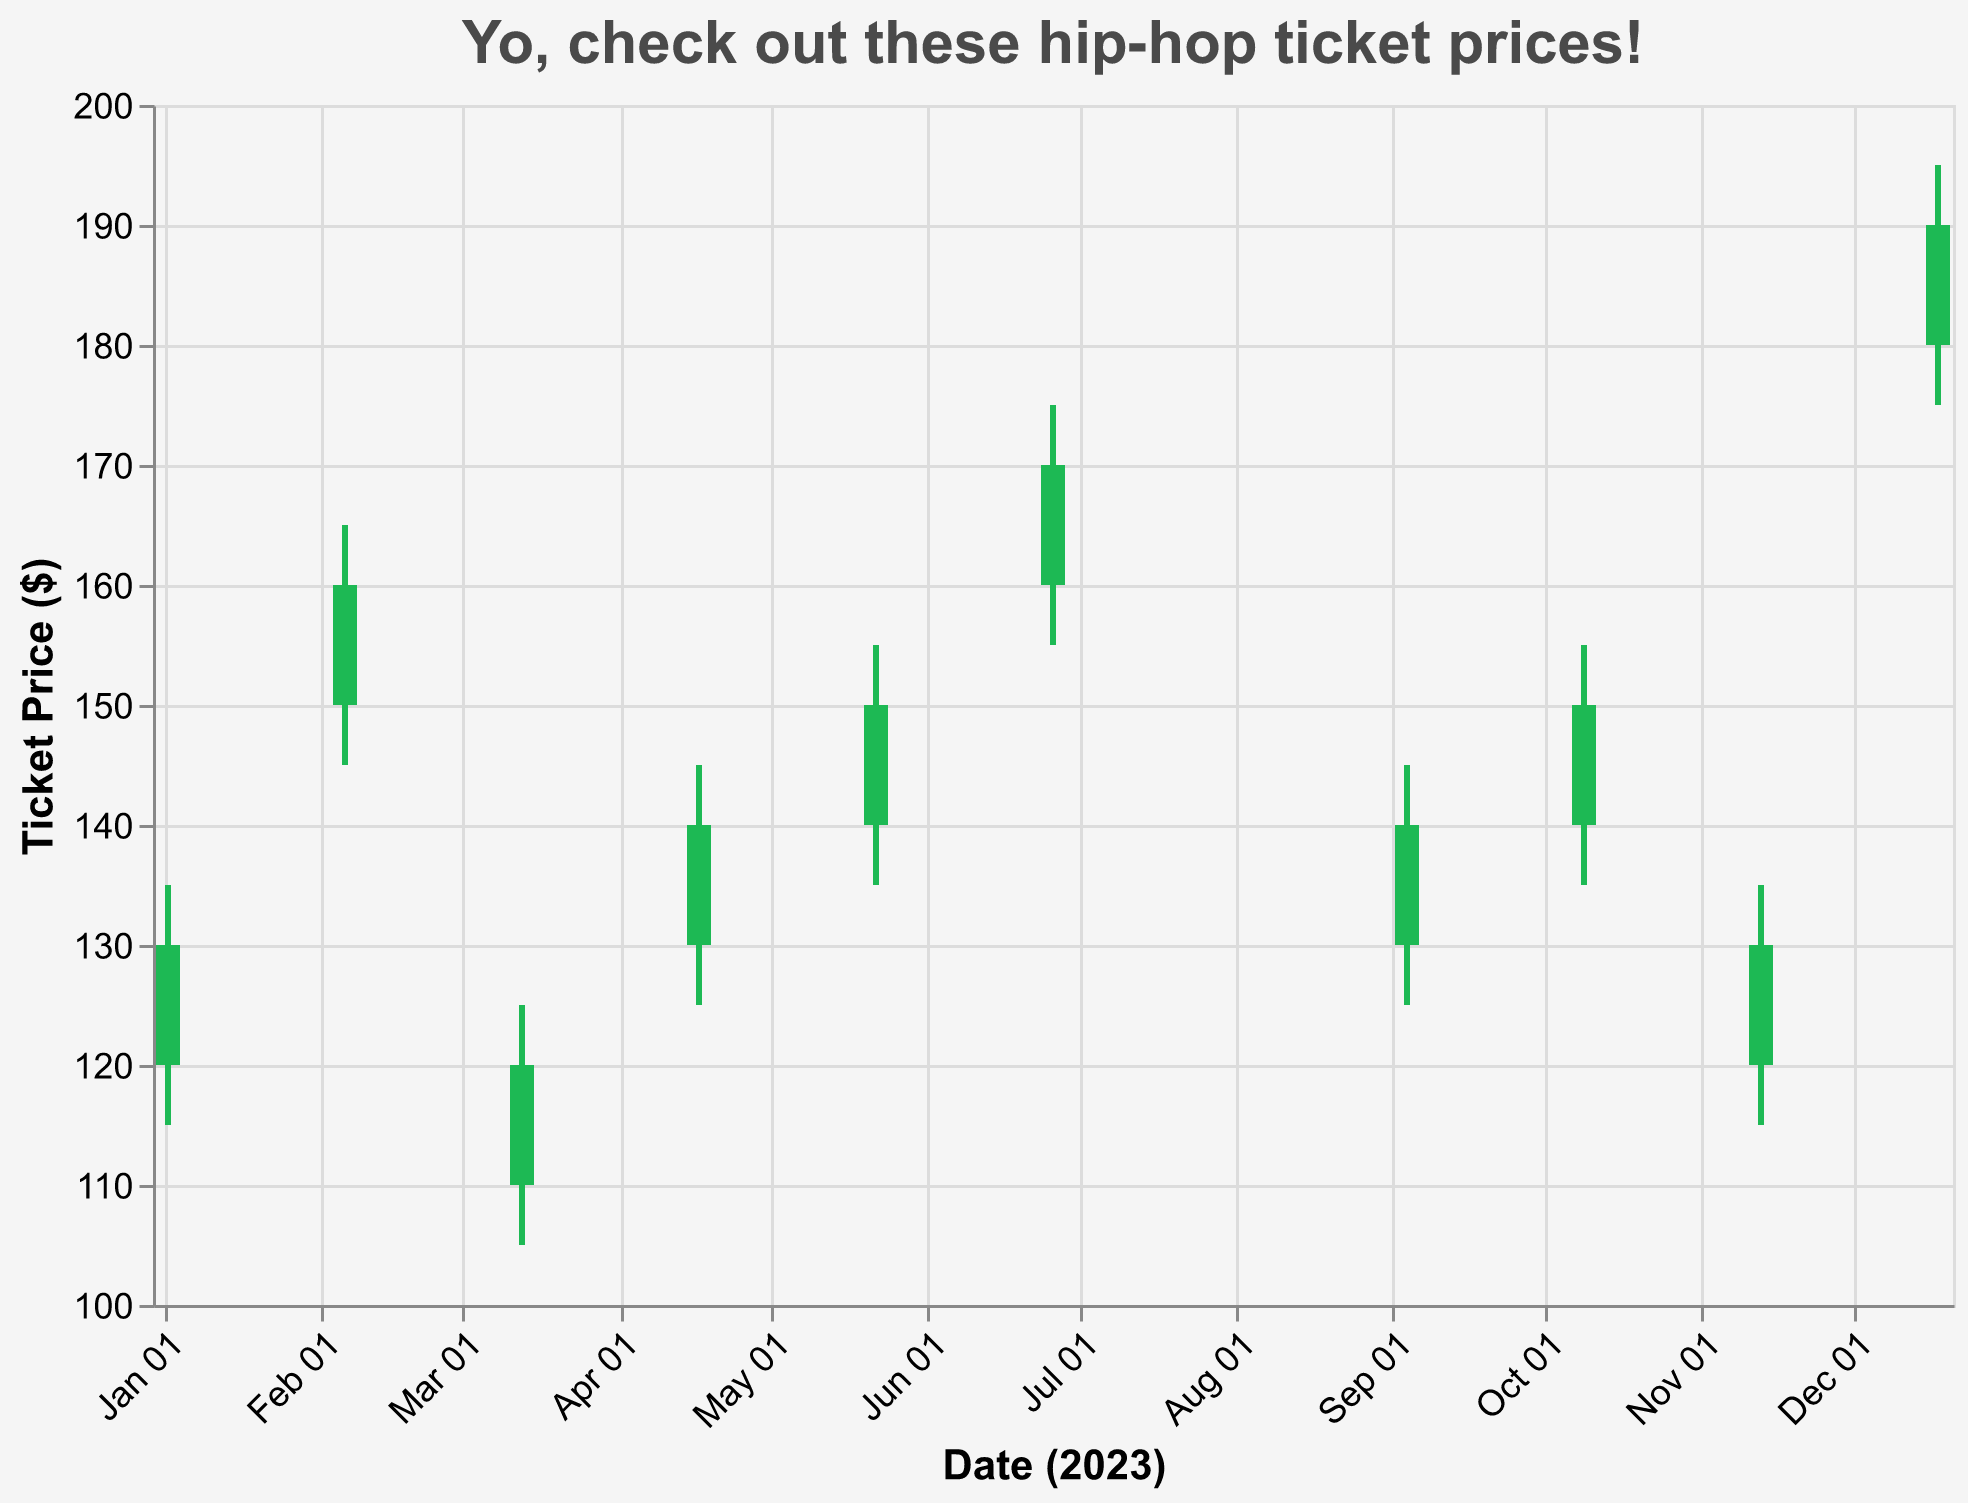What is the title of the chart? The title is located at the top of the chart, providing an overview of the plot's content. It's written in a larger font size.
Answer: Yo, check out these hip-hop ticket prices! How many concerts are represented in the chart? Count the number of unique data points, each corresponding to a different concert.
Answer: 10 Which concert had the highest closing ticket price? Look for the highest value in the "Close" field on the y-axis.
Answer: Post Malone - Twelve Carat Tour Did any concert have the same opening and closing ticket prices? Check if any value in the "Open" field matches its corresponding value in the "Close" field.
Answer: No What is the range of ticket prices for Kendrick Lamar's concert? Subtract the Low price from the High price for Kendrick Lamar's concert. The range is High - Low.
Answer: 20 Which concert had the lowest opening ticket price? Look for the lowest value in the "Open" field.
Answer: J. Cole - The Off-Season Tour How much did the ticket price increase for Drake's concert? Subtract the Open price from the Close price for Drake's concert. The increase is Close - Open.
Answer: 10 Which concert had the greatest difference between its high and low prices? For each concert, calculate the difference between the High and Low prices and find the maximum difference.
Answer: Post Malone - Twelve Carat Tour What is the average closing price for all concerts? Sum all Close prices and divide by the number of concerts. The average is (130 + 160 + 120 + 140 + 150 + 170 + 140 + 150 + 130 + 190) / 10.
Answer: 138 